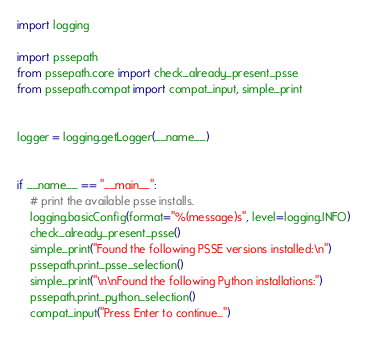<code> <loc_0><loc_0><loc_500><loc_500><_Python_>import logging

import pssepath
from pssepath.core import check_already_present_psse
from pssepath.compat import compat_input, simple_print


logger = logging.getLogger(__name__)


if __name__ == "__main__":
    # print the available psse installs.
    logging.basicConfig(format="%(message)s", level=logging.INFO)
    check_already_present_psse()
    simple_print("Found the following PSSE versions installed:\n")
    pssepath.print_psse_selection()
    simple_print("\n\nFound the following Python installations:")
    pssepath.print_python_selection()
    compat_input("Press Enter to continue...")
</code> 